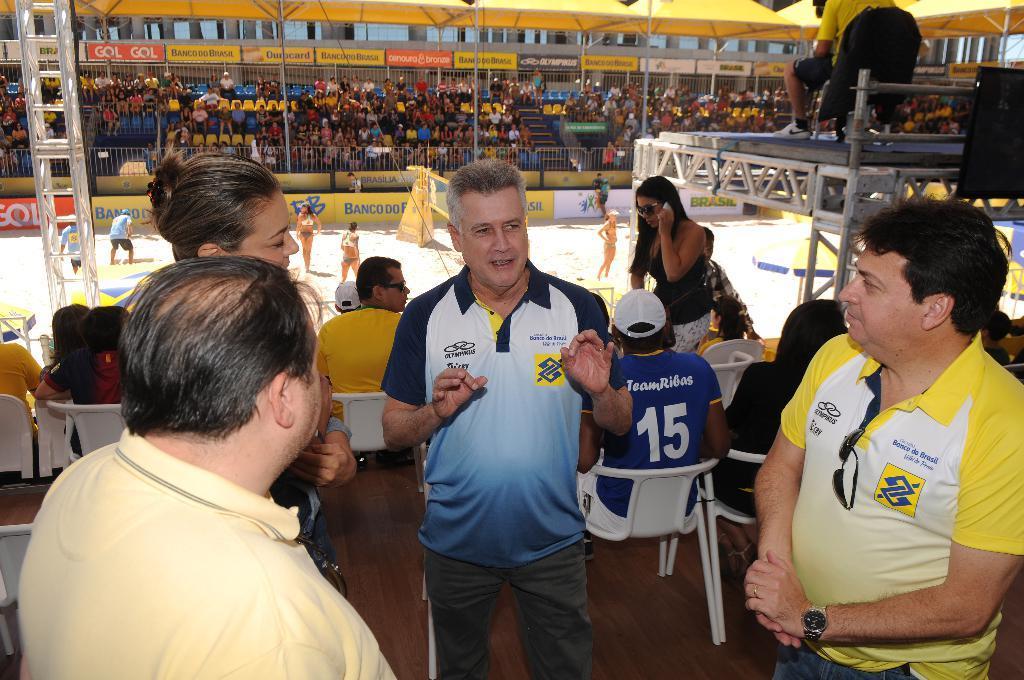How would you summarize this image in a sentence or two? In this picture there are some people standing and talking. There were men and women in this picture. Some of them were sitting in the background, in the chairs. In the background there is a court in which there are some players are playing a game. There is a net. In the background there are some people sitting in the chairs behind this railing. 